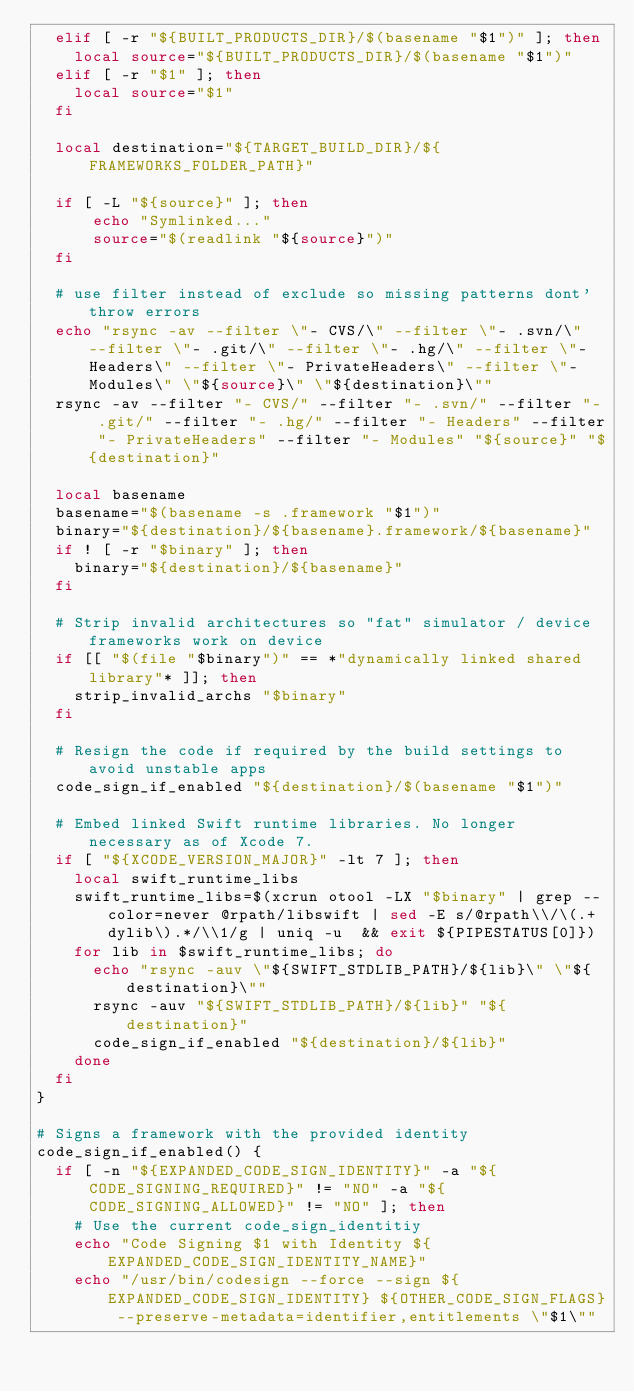<code> <loc_0><loc_0><loc_500><loc_500><_Bash_>  elif [ -r "${BUILT_PRODUCTS_DIR}/$(basename "$1")" ]; then
    local source="${BUILT_PRODUCTS_DIR}/$(basename "$1")"
  elif [ -r "$1" ]; then
    local source="$1"
  fi

  local destination="${TARGET_BUILD_DIR}/${FRAMEWORKS_FOLDER_PATH}"

  if [ -L "${source}" ]; then
      echo "Symlinked..."
      source="$(readlink "${source}")"
  fi

  # use filter instead of exclude so missing patterns dont' throw errors
  echo "rsync -av --filter \"- CVS/\" --filter \"- .svn/\" --filter \"- .git/\" --filter \"- .hg/\" --filter \"- Headers\" --filter \"- PrivateHeaders\" --filter \"- Modules\" \"${source}\" \"${destination}\""
  rsync -av --filter "- CVS/" --filter "- .svn/" --filter "- .git/" --filter "- .hg/" --filter "- Headers" --filter "- PrivateHeaders" --filter "- Modules" "${source}" "${destination}"

  local basename
  basename="$(basename -s .framework "$1")"
  binary="${destination}/${basename}.framework/${basename}"
  if ! [ -r "$binary" ]; then
    binary="${destination}/${basename}"
  fi

  # Strip invalid architectures so "fat" simulator / device frameworks work on device
  if [[ "$(file "$binary")" == *"dynamically linked shared library"* ]]; then
    strip_invalid_archs "$binary"
  fi

  # Resign the code if required by the build settings to avoid unstable apps
  code_sign_if_enabled "${destination}/$(basename "$1")"

  # Embed linked Swift runtime libraries. No longer necessary as of Xcode 7.
  if [ "${XCODE_VERSION_MAJOR}" -lt 7 ]; then
    local swift_runtime_libs
    swift_runtime_libs=$(xcrun otool -LX "$binary" | grep --color=never @rpath/libswift | sed -E s/@rpath\\/\(.+dylib\).*/\\1/g | uniq -u  && exit ${PIPESTATUS[0]})
    for lib in $swift_runtime_libs; do
      echo "rsync -auv \"${SWIFT_STDLIB_PATH}/${lib}\" \"${destination}\""
      rsync -auv "${SWIFT_STDLIB_PATH}/${lib}" "${destination}"
      code_sign_if_enabled "${destination}/${lib}"
    done
  fi
}

# Signs a framework with the provided identity
code_sign_if_enabled() {
  if [ -n "${EXPANDED_CODE_SIGN_IDENTITY}" -a "${CODE_SIGNING_REQUIRED}" != "NO" -a "${CODE_SIGNING_ALLOWED}" != "NO" ]; then
    # Use the current code_sign_identitiy
    echo "Code Signing $1 with Identity ${EXPANDED_CODE_SIGN_IDENTITY_NAME}"
    echo "/usr/bin/codesign --force --sign ${EXPANDED_CODE_SIGN_IDENTITY} ${OTHER_CODE_SIGN_FLAGS} --preserve-metadata=identifier,entitlements \"$1\""</code> 